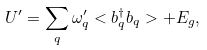Convert formula to latex. <formula><loc_0><loc_0><loc_500><loc_500>U ^ { \prime } = \sum _ { q } \omega _ { q } ^ { \prime } < b _ { q } ^ { \dagger } b _ { q } > + E _ { g } ,</formula> 